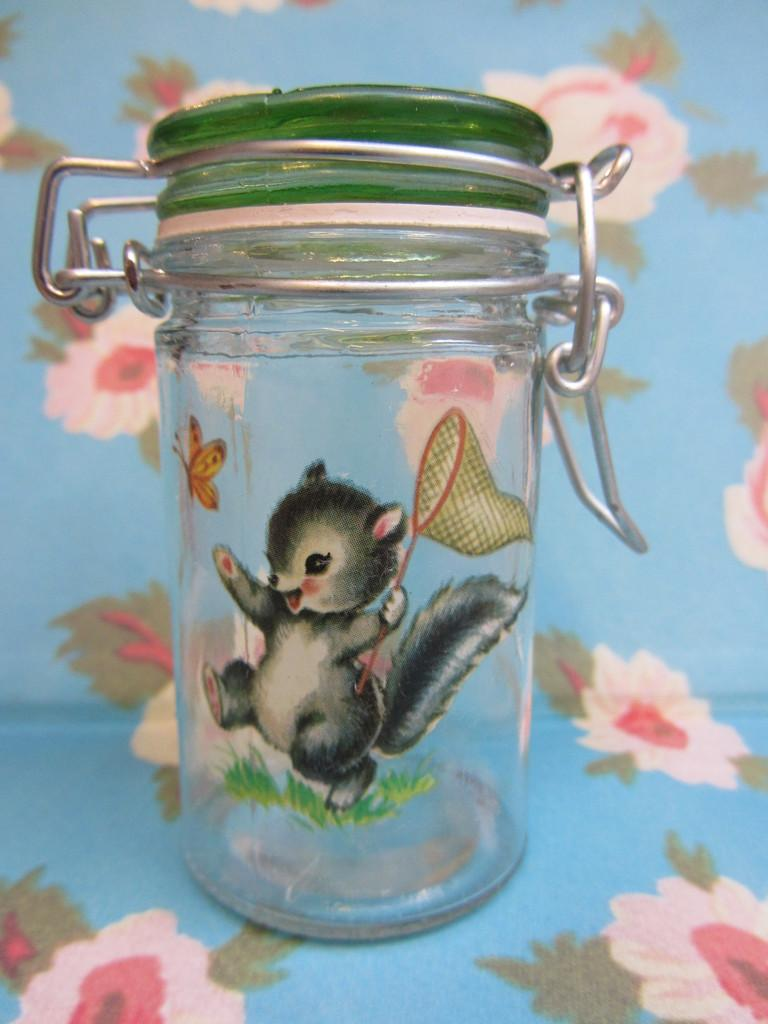What object is present in the image that can hold items? There is a jar in the image that can hold items. What feature does the jar have to keep its contents secure? The jar has a lid. What color is the lid of the jar? The lid is green in color. Where is the jar placed in the image? The jar is on a mat. What color is the mat? The mat is blue in color. What type of destruction is depicted in the image? There is no destruction depicted in the image; it features a jar with a green lid on a blue mat. What country is the jar from in the image? The image does not provide information about the country of origin for the jar. 